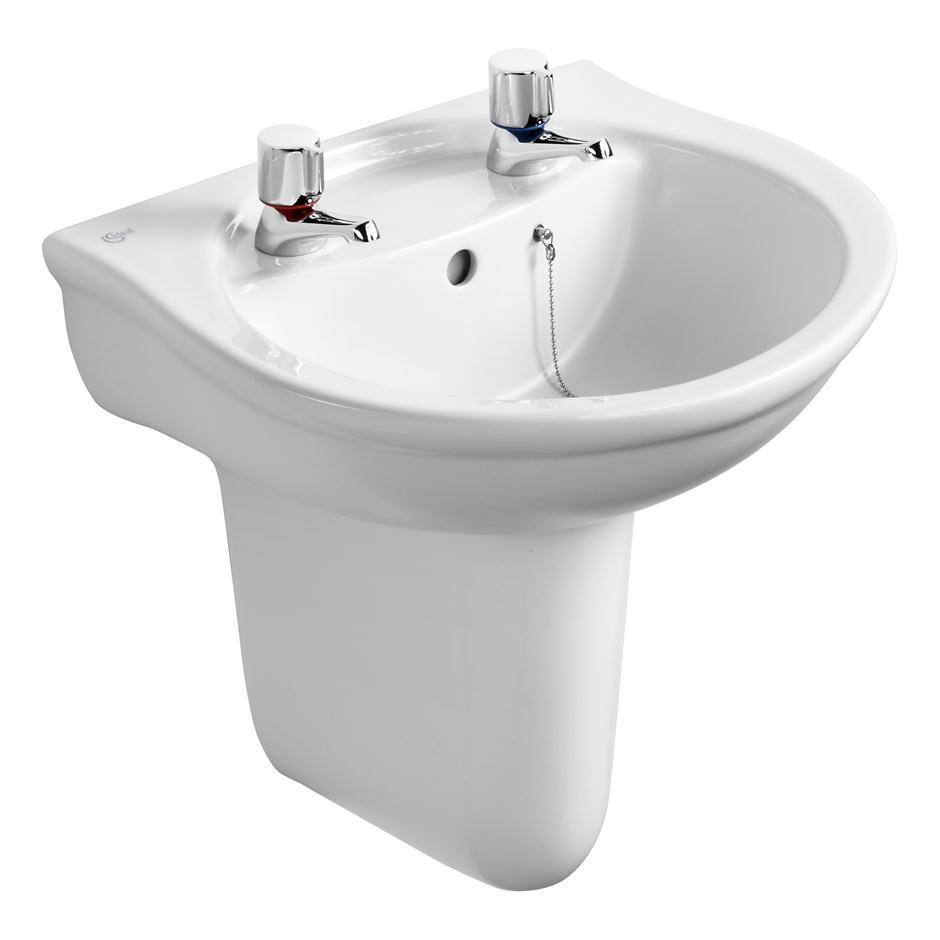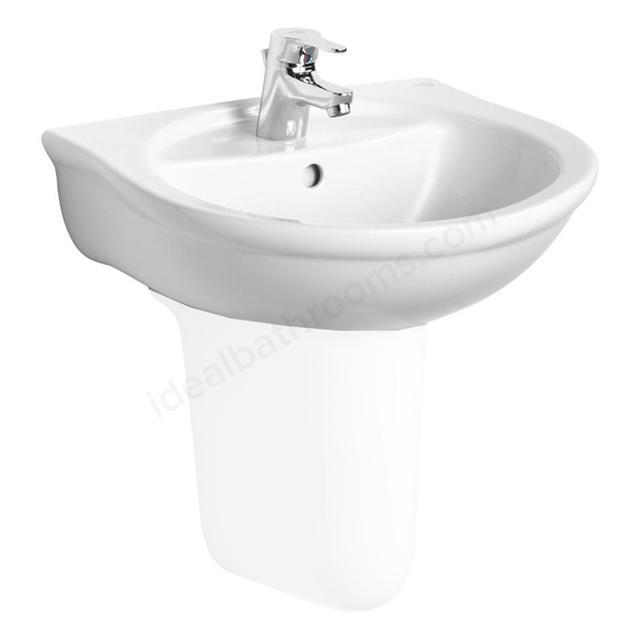The first image is the image on the left, the second image is the image on the right. Analyze the images presented: Is the assertion "The drain in the bottom of the basin is visible in the image on the right." valid? Answer yes or no. No. 